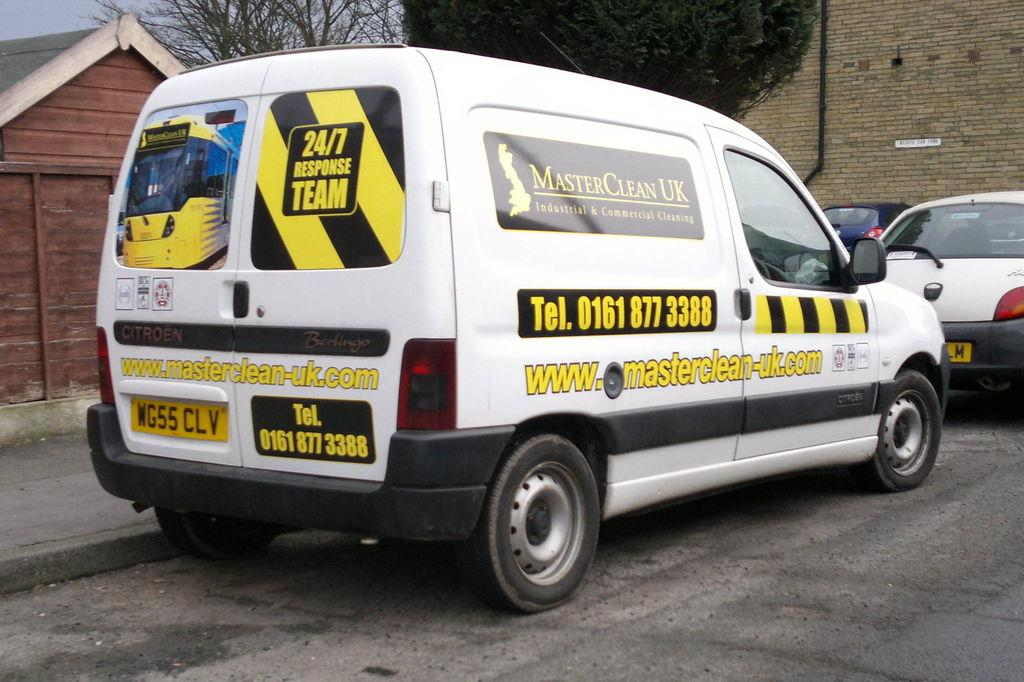<image>
Share a concise interpretation of the image provided. a MasterClean UK sign that is on a car 